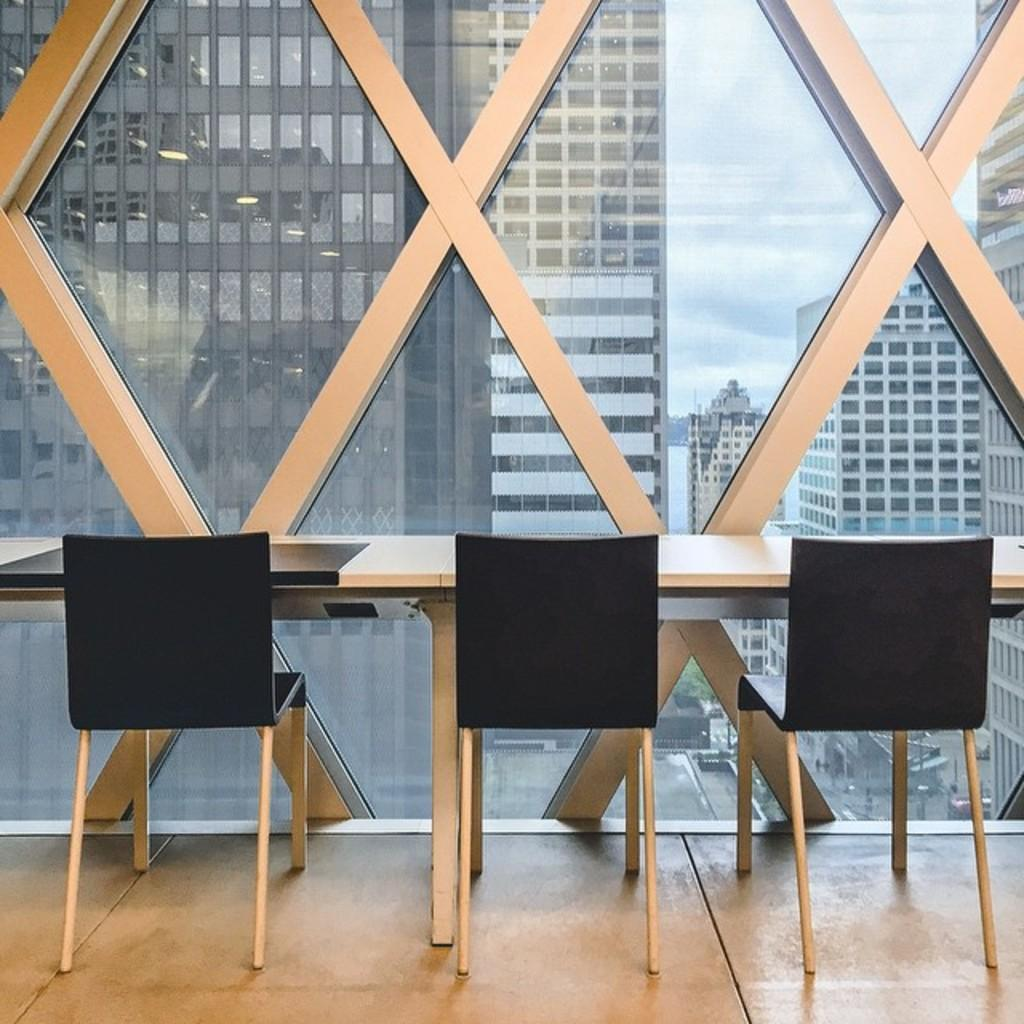How many chairs are in the image? There are three black chairs in the image. What are the chairs positioned in front of? The chairs are in front of tables. What can be seen in the background of the image? There are buildings and clouds visible in the sky in the background of the image. What type of marble is used to decorate the pizzas in the image? There are no pizzas present in the image, and therefore no marble can be observed on them. 